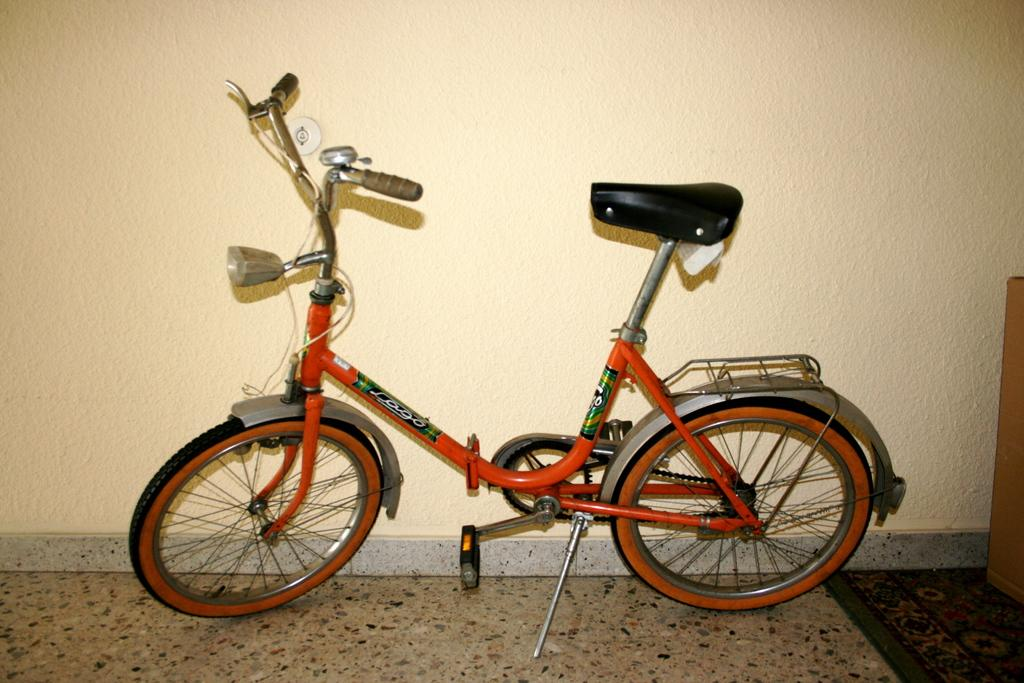What is the main object in the image? There is a bicycle in the image. Where is the bicycle located? The bicycle is on the floor. What else can be seen in the image besides the bicycle? There is a wall visible in the image. What type of weather is depicted in the image? There is no weather depicted in the image, as it only features a bicycle on the floor and a wall. 